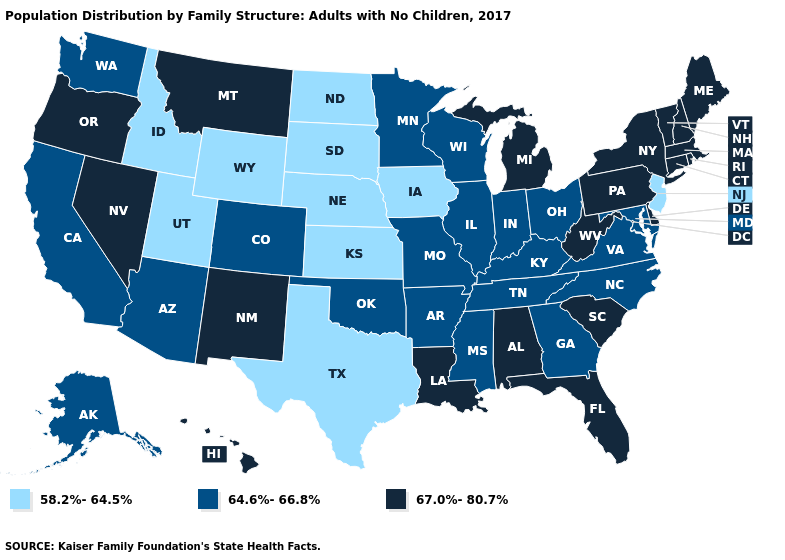Does Vermont have a higher value than Michigan?
Keep it brief. No. Name the states that have a value in the range 67.0%-80.7%?
Give a very brief answer. Alabama, Connecticut, Delaware, Florida, Hawaii, Louisiana, Maine, Massachusetts, Michigan, Montana, Nevada, New Hampshire, New Mexico, New York, Oregon, Pennsylvania, Rhode Island, South Carolina, Vermont, West Virginia. What is the lowest value in the USA?
Be succinct. 58.2%-64.5%. Name the states that have a value in the range 64.6%-66.8%?
Concise answer only. Alaska, Arizona, Arkansas, California, Colorado, Georgia, Illinois, Indiana, Kentucky, Maryland, Minnesota, Mississippi, Missouri, North Carolina, Ohio, Oklahoma, Tennessee, Virginia, Washington, Wisconsin. Among the states that border Idaho , does Utah have the highest value?
Answer briefly. No. Name the states that have a value in the range 67.0%-80.7%?
Quick response, please. Alabama, Connecticut, Delaware, Florida, Hawaii, Louisiana, Maine, Massachusetts, Michigan, Montana, Nevada, New Hampshire, New Mexico, New York, Oregon, Pennsylvania, Rhode Island, South Carolina, Vermont, West Virginia. Does Mississippi have a higher value than Iowa?
Write a very short answer. Yes. Does Nebraska have the lowest value in the USA?
Write a very short answer. Yes. What is the value of New Jersey?
Concise answer only. 58.2%-64.5%. Name the states that have a value in the range 64.6%-66.8%?
Write a very short answer. Alaska, Arizona, Arkansas, California, Colorado, Georgia, Illinois, Indiana, Kentucky, Maryland, Minnesota, Mississippi, Missouri, North Carolina, Ohio, Oklahoma, Tennessee, Virginia, Washington, Wisconsin. What is the value of Illinois?
Short answer required. 64.6%-66.8%. Name the states that have a value in the range 64.6%-66.8%?
Keep it brief. Alaska, Arizona, Arkansas, California, Colorado, Georgia, Illinois, Indiana, Kentucky, Maryland, Minnesota, Mississippi, Missouri, North Carolina, Ohio, Oklahoma, Tennessee, Virginia, Washington, Wisconsin. Does Idaho have a higher value than Alabama?
Be succinct. No. Among the states that border Maryland , does Virginia have the highest value?
Short answer required. No. What is the highest value in the USA?
Write a very short answer. 67.0%-80.7%. 